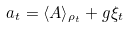<formula> <loc_0><loc_0><loc_500><loc_500>a _ { t } = \langle A \rangle _ { \rho _ { t } } + g \xi _ { t }</formula> 